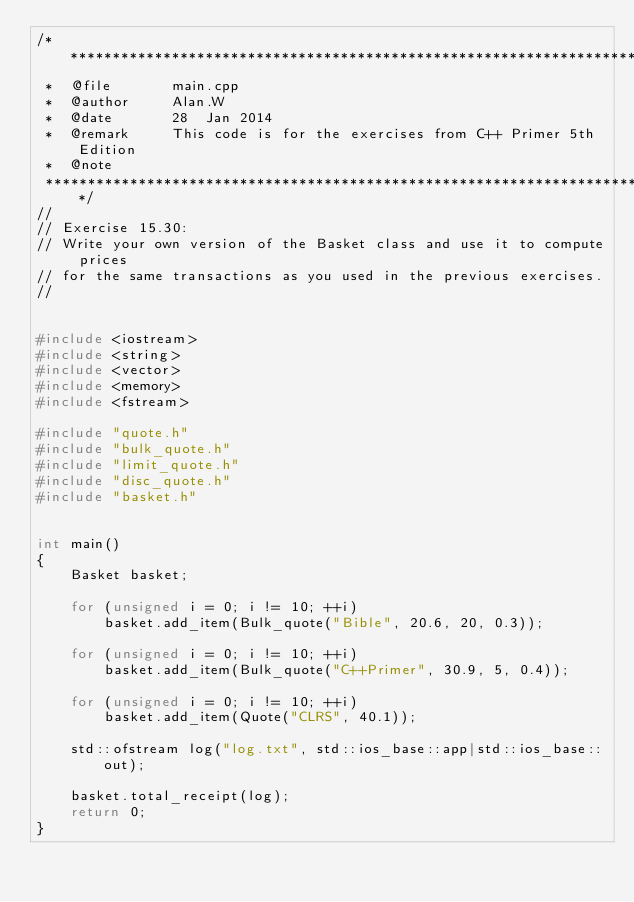<code> <loc_0><loc_0><loc_500><loc_500><_C++_>/***************************************************************************
 *  @file       main.cpp
 *  @author     Alan.W
 *  @date       28  Jan 2014
 *  @remark     This code is for the exercises from C++ Primer 5th Edition
 *  @note
 ***************************************************************************/
//
// Exercise 15.30:
// Write your own version of the Basket class and use it to compute prices
// for the same transactions as you used in the previous exercises.
//


#include <iostream>
#include <string>
#include <vector>
#include <memory>
#include <fstream>

#include "quote.h"
#include "bulk_quote.h"
#include "limit_quote.h"
#include "disc_quote.h"
#include "basket.h"


int main()
{
    Basket basket;

    for (unsigned i = 0; i != 10; ++i)
        basket.add_item(Bulk_quote("Bible", 20.6, 20, 0.3));

    for (unsigned i = 0; i != 10; ++i)
        basket.add_item(Bulk_quote("C++Primer", 30.9, 5, 0.4));

    for (unsigned i = 0; i != 10; ++i)
        basket.add_item(Quote("CLRS", 40.1));

    std::ofstream log("log.txt", std::ios_base::app|std::ios_base::out);

    basket.total_receipt(log);
    return 0;
}
</code> 